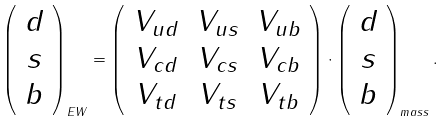Convert formula to latex. <formula><loc_0><loc_0><loc_500><loc_500>\left ( \begin{array} { c } d \\ s \\ b \end{array} \right ) _ { E W } = \left ( \begin{array} { c c c } V _ { u d } & V _ { u s } & V _ { u b } \\ V _ { c d } & V _ { c s } & V _ { c b } \\ V _ { t d } & V _ { t s } & V _ { t b } \end{array} \right ) \cdot \left ( \begin{array} { c } d \\ s \\ b \end{array} \right ) _ { m a s s } .</formula> 